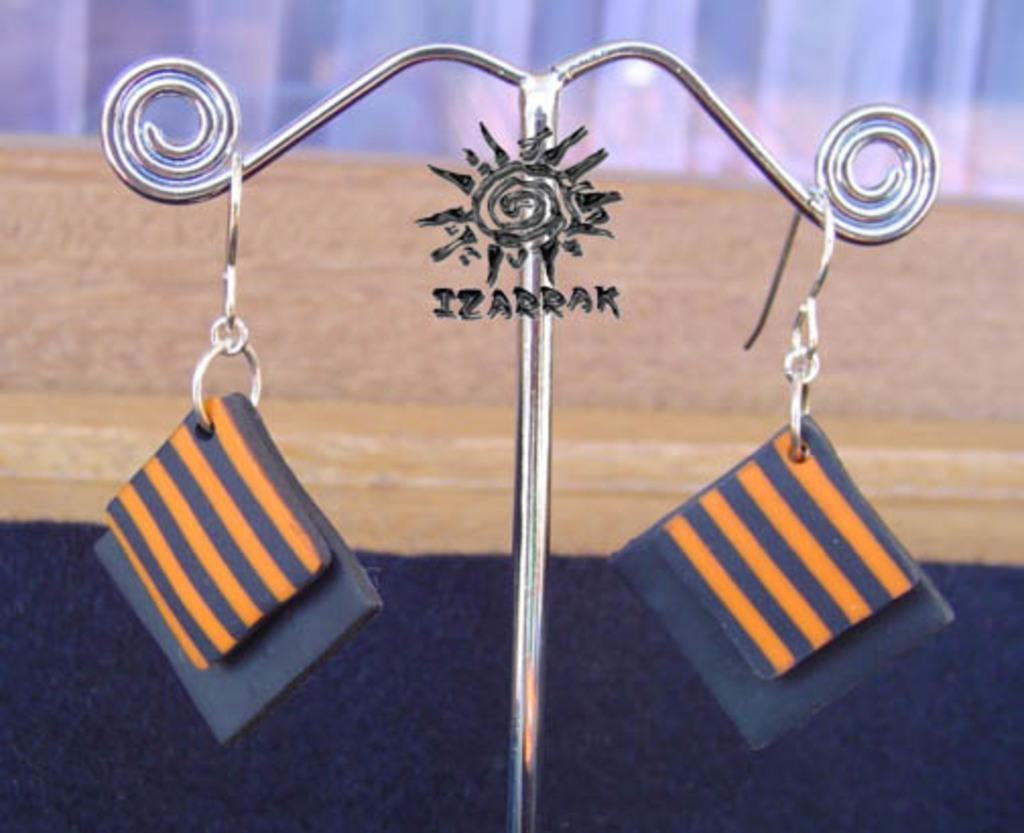What object is the main focus of the image? There is an earring stand in the image. What is attached to the earring stand? The earring stand has an earring. Can you describe the earring? The earring is blue in color and has a square shape, with orange lines on it. What can be seen in the background of the image? There is a wooden plank in the background of the image. What type of event is taking place in the image? There is no event taking place in the image; it simply shows an earring stand with an earring and a wooden plank in the background. Can you tell me which mountain is visible in the image? There are no mountains visible in the image. 